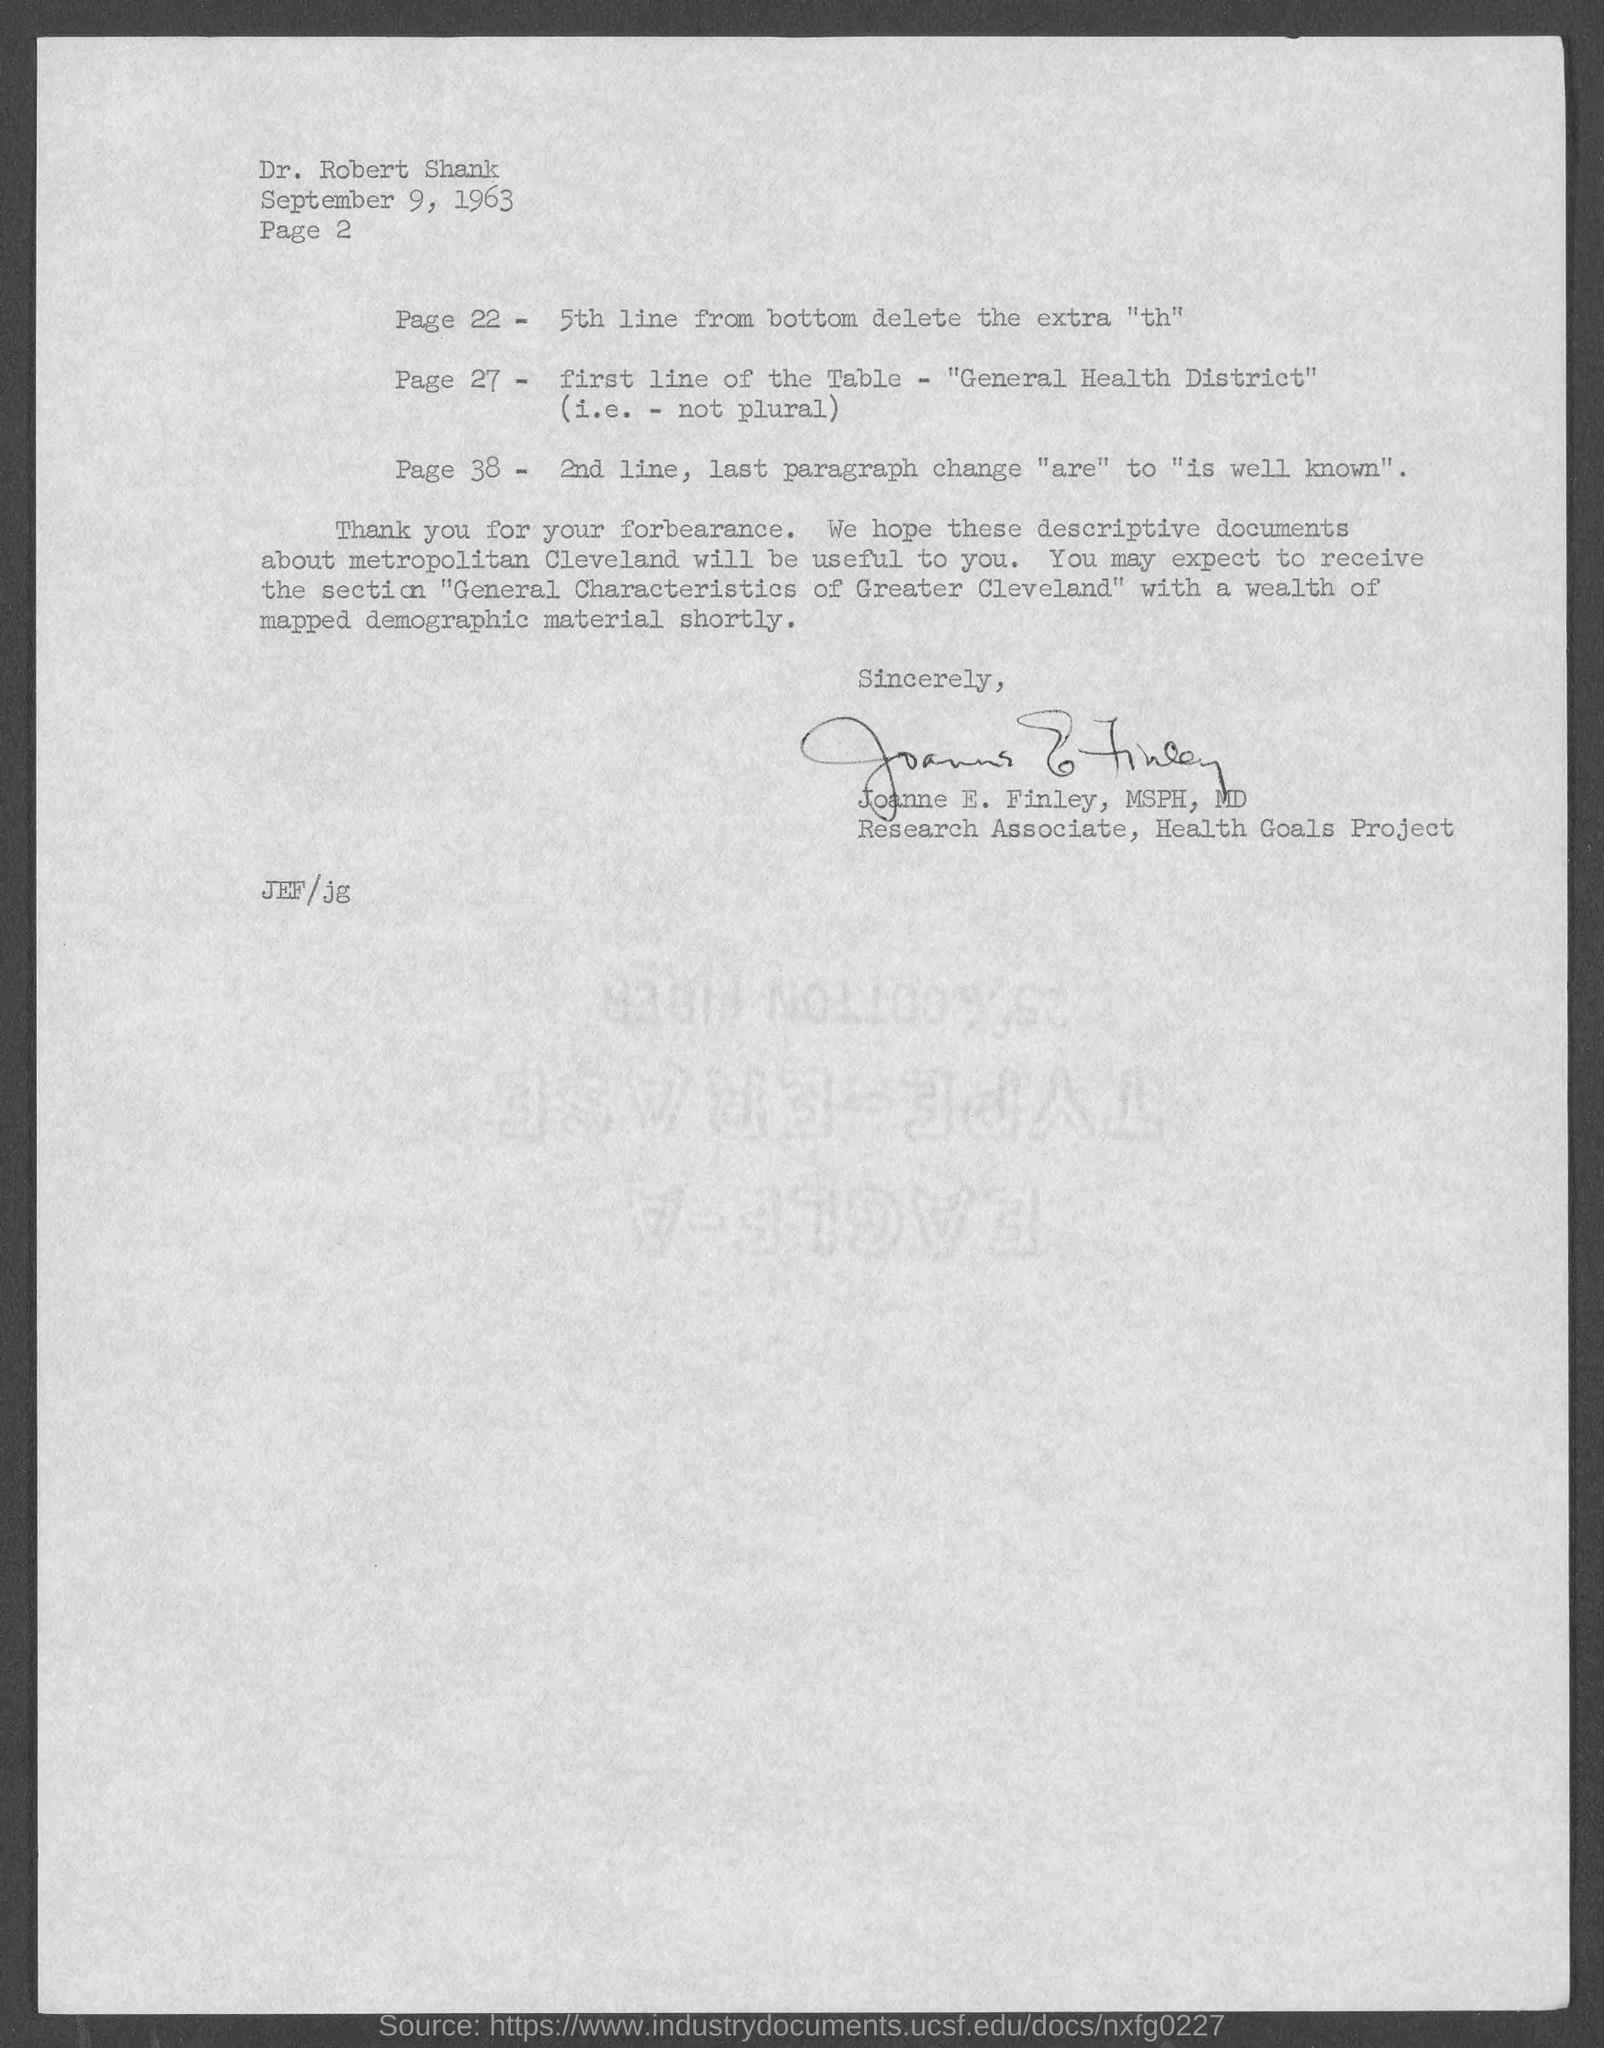Draw attention to some important aspects in this diagram. The date mentioned in this letter is September 9, 1963. Joanne E. Finley, MSPH, MD, has signed this letter. Joanne E. Finley, MSPH, MD is a Research Associate for the Health Goals Project. The addressee of this letter is Dr. Robert Shank. 